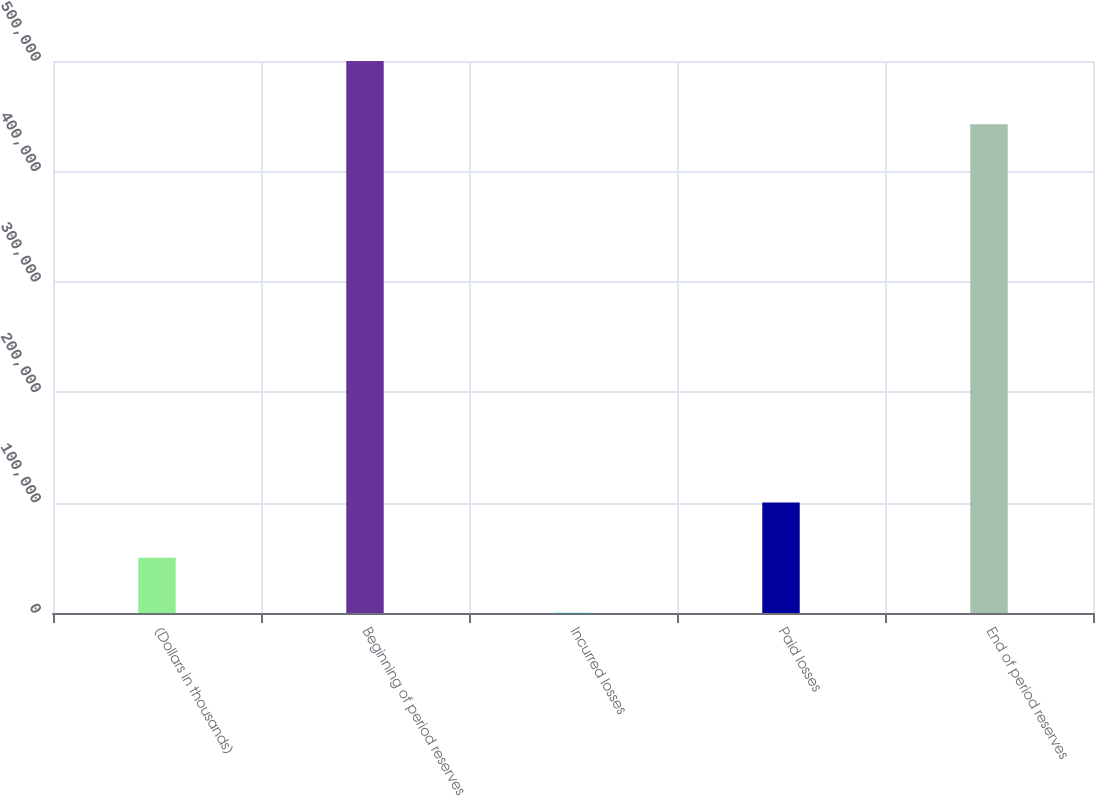Convert chart. <chart><loc_0><loc_0><loc_500><loc_500><bar_chart><fcel>(Dollars in thousands)<fcel>Beginning of period reserves<fcel>Incurred losses<fcel>Paid losses<fcel>End of period reserves<nl><fcel>50109.9<fcel>499911<fcel>132<fcel>100088<fcel>442821<nl></chart> 